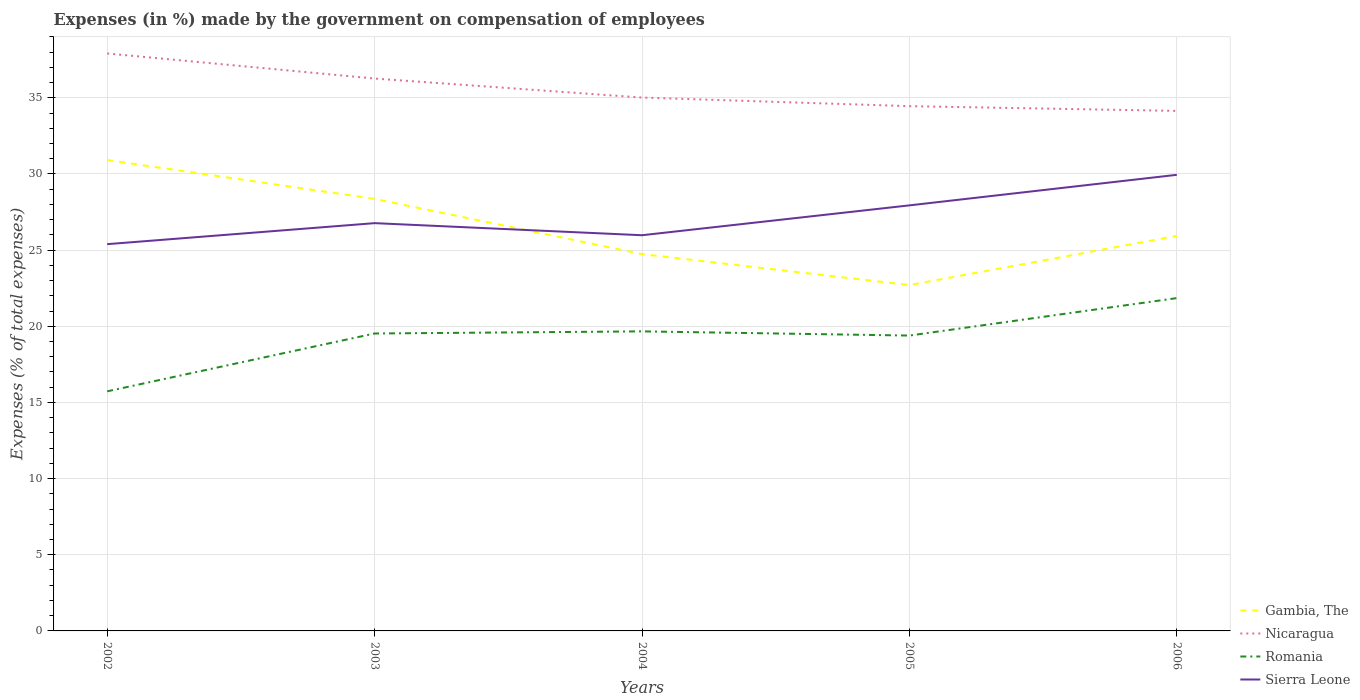How many different coloured lines are there?
Ensure brevity in your answer.  4. Does the line corresponding to Romania intersect with the line corresponding to Gambia, The?
Your response must be concise. No. Across all years, what is the maximum percentage of expenses made by the government on compensation of employees in Sierra Leone?
Your response must be concise. 25.39. What is the total percentage of expenses made by the government on compensation of employees in Nicaragua in the graph?
Your answer should be very brief. 0.88. What is the difference between the highest and the second highest percentage of expenses made by the government on compensation of employees in Romania?
Provide a succinct answer. 6.12. Are the values on the major ticks of Y-axis written in scientific E-notation?
Make the answer very short. No. Does the graph contain any zero values?
Your answer should be very brief. No. Does the graph contain grids?
Ensure brevity in your answer.  Yes. Where does the legend appear in the graph?
Provide a short and direct response. Bottom right. How are the legend labels stacked?
Your response must be concise. Vertical. What is the title of the graph?
Provide a short and direct response. Expenses (in %) made by the government on compensation of employees. Does "Moldova" appear as one of the legend labels in the graph?
Keep it short and to the point. No. What is the label or title of the X-axis?
Your answer should be very brief. Years. What is the label or title of the Y-axis?
Provide a succinct answer. Expenses (% of total expenses). What is the Expenses (% of total expenses) in Gambia, The in 2002?
Make the answer very short. 30.92. What is the Expenses (% of total expenses) of Nicaragua in 2002?
Offer a terse response. 37.91. What is the Expenses (% of total expenses) in Romania in 2002?
Your answer should be compact. 15.73. What is the Expenses (% of total expenses) of Sierra Leone in 2002?
Give a very brief answer. 25.39. What is the Expenses (% of total expenses) of Gambia, The in 2003?
Provide a short and direct response. 28.37. What is the Expenses (% of total expenses) of Nicaragua in 2003?
Ensure brevity in your answer.  36.26. What is the Expenses (% of total expenses) in Romania in 2003?
Provide a succinct answer. 19.53. What is the Expenses (% of total expenses) in Sierra Leone in 2003?
Provide a short and direct response. 26.77. What is the Expenses (% of total expenses) in Gambia, The in 2004?
Your answer should be compact. 24.74. What is the Expenses (% of total expenses) in Nicaragua in 2004?
Give a very brief answer. 35.02. What is the Expenses (% of total expenses) in Romania in 2004?
Ensure brevity in your answer.  19.67. What is the Expenses (% of total expenses) in Sierra Leone in 2004?
Offer a terse response. 25.98. What is the Expenses (% of total expenses) of Gambia, The in 2005?
Your answer should be compact. 22.71. What is the Expenses (% of total expenses) in Nicaragua in 2005?
Make the answer very short. 34.45. What is the Expenses (% of total expenses) in Romania in 2005?
Make the answer very short. 19.39. What is the Expenses (% of total expenses) of Sierra Leone in 2005?
Provide a short and direct response. 27.94. What is the Expenses (% of total expenses) of Gambia, The in 2006?
Provide a short and direct response. 25.94. What is the Expenses (% of total expenses) in Nicaragua in 2006?
Ensure brevity in your answer.  34.14. What is the Expenses (% of total expenses) in Romania in 2006?
Offer a very short reply. 21.85. What is the Expenses (% of total expenses) in Sierra Leone in 2006?
Provide a succinct answer. 29.94. Across all years, what is the maximum Expenses (% of total expenses) of Gambia, The?
Give a very brief answer. 30.92. Across all years, what is the maximum Expenses (% of total expenses) of Nicaragua?
Offer a very short reply. 37.91. Across all years, what is the maximum Expenses (% of total expenses) in Romania?
Ensure brevity in your answer.  21.85. Across all years, what is the maximum Expenses (% of total expenses) in Sierra Leone?
Your answer should be compact. 29.94. Across all years, what is the minimum Expenses (% of total expenses) of Gambia, The?
Your answer should be compact. 22.71. Across all years, what is the minimum Expenses (% of total expenses) of Nicaragua?
Provide a short and direct response. 34.14. Across all years, what is the minimum Expenses (% of total expenses) in Romania?
Keep it short and to the point. 15.73. Across all years, what is the minimum Expenses (% of total expenses) in Sierra Leone?
Your response must be concise. 25.39. What is the total Expenses (% of total expenses) of Gambia, The in the graph?
Keep it short and to the point. 132.67. What is the total Expenses (% of total expenses) of Nicaragua in the graph?
Provide a succinct answer. 177.78. What is the total Expenses (% of total expenses) in Romania in the graph?
Offer a very short reply. 96.16. What is the total Expenses (% of total expenses) in Sierra Leone in the graph?
Provide a succinct answer. 136.02. What is the difference between the Expenses (% of total expenses) in Gambia, The in 2002 and that in 2003?
Give a very brief answer. 2.55. What is the difference between the Expenses (% of total expenses) in Nicaragua in 2002 and that in 2003?
Make the answer very short. 1.65. What is the difference between the Expenses (% of total expenses) in Romania in 2002 and that in 2003?
Your response must be concise. -3.8. What is the difference between the Expenses (% of total expenses) of Sierra Leone in 2002 and that in 2003?
Give a very brief answer. -1.38. What is the difference between the Expenses (% of total expenses) of Gambia, The in 2002 and that in 2004?
Provide a succinct answer. 6.18. What is the difference between the Expenses (% of total expenses) in Nicaragua in 2002 and that in 2004?
Provide a short and direct response. 2.89. What is the difference between the Expenses (% of total expenses) in Romania in 2002 and that in 2004?
Provide a succinct answer. -3.94. What is the difference between the Expenses (% of total expenses) in Sierra Leone in 2002 and that in 2004?
Offer a very short reply. -0.59. What is the difference between the Expenses (% of total expenses) in Gambia, The in 2002 and that in 2005?
Offer a very short reply. 8.21. What is the difference between the Expenses (% of total expenses) in Nicaragua in 2002 and that in 2005?
Keep it short and to the point. 3.46. What is the difference between the Expenses (% of total expenses) of Romania in 2002 and that in 2005?
Give a very brief answer. -3.66. What is the difference between the Expenses (% of total expenses) in Sierra Leone in 2002 and that in 2005?
Keep it short and to the point. -2.55. What is the difference between the Expenses (% of total expenses) of Gambia, The in 2002 and that in 2006?
Offer a very short reply. 4.98. What is the difference between the Expenses (% of total expenses) in Nicaragua in 2002 and that in 2006?
Provide a succinct answer. 3.77. What is the difference between the Expenses (% of total expenses) in Romania in 2002 and that in 2006?
Offer a very short reply. -6.12. What is the difference between the Expenses (% of total expenses) in Sierra Leone in 2002 and that in 2006?
Your answer should be very brief. -4.55. What is the difference between the Expenses (% of total expenses) of Gambia, The in 2003 and that in 2004?
Your answer should be compact. 3.63. What is the difference between the Expenses (% of total expenses) in Nicaragua in 2003 and that in 2004?
Provide a short and direct response. 1.25. What is the difference between the Expenses (% of total expenses) of Romania in 2003 and that in 2004?
Offer a terse response. -0.14. What is the difference between the Expenses (% of total expenses) of Sierra Leone in 2003 and that in 2004?
Provide a short and direct response. 0.79. What is the difference between the Expenses (% of total expenses) of Gambia, The in 2003 and that in 2005?
Give a very brief answer. 5.66. What is the difference between the Expenses (% of total expenses) in Nicaragua in 2003 and that in 2005?
Provide a short and direct response. 1.81. What is the difference between the Expenses (% of total expenses) in Romania in 2003 and that in 2005?
Make the answer very short. 0.14. What is the difference between the Expenses (% of total expenses) of Sierra Leone in 2003 and that in 2005?
Make the answer very short. -1.17. What is the difference between the Expenses (% of total expenses) of Gambia, The in 2003 and that in 2006?
Your answer should be compact. 2.43. What is the difference between the Expenses (% of total expenses) of Nicaragua in 2003 and that in 2006?
Offer a terse response. 2.12. What is the difference between the Expenses (% of total expenses) in Romania in 2003 and that in 2006?
Ensure brevity in your answer.  -2.32. What is the difference between the Expenses (% of total expenses) in Sierra Leone in 2003 and that in 2006?
Ensure brevity in your answer.  -3.17. What is the difference between the Expenses (% of total expenses) of Gambia, The in 2004 and that in 2005?
Provide a short and direct response. 2.03. What is the difference between the Expenses (% of total expenses) in Nicaragua in 2004 and that in 2005?
Provide a short and direct response. 0.56. What is the difference between the Expenses (% of total expenses) in Romania in 2004 and that in 2005?
Offer a terse response. 0.27. What is the difference between the Expenses (% of total expenses) in Sierra Leone in 2004 and that in 2005?
Your answer should be very brief. -1.96. What is the difference between the Expenses (% of total expenses) in Gambia, The in 2004 and that in 2006?
Provide a succinct answer. -1.19. What is the difference between the Expenses (% of total expenses) of Nicaragua in 2004 and that in 2006?
Provide a succinct answer. 0.88. What is the difference between the Expenses (% of total expenses) in Romania in 2004 and that in 2006?
Provide a short and direct response. -2.18. What is the difference between the Expenses (% of total expenses) of Sierra Leone in 2004 and that in 2006?
Your answer should be compact. -3.97. What is the difference between the Expenses (% of total expenses) of Gambia, The in 2005 and that in 2006?
Keep it short and to the point. -3.23. What is the difference between the Expenses (% of total expenses) of Nicaragua in 2005 and that in 2006?
Keep it short and to the point. 0.31. What is the difference between the Expenses (% of total expenses) in Romania in 2005 and that in 2006?
Provide a short and direct response. -2.46. What is the difference between the Expenses (% of total expenses) in Sierra Leone in 2005 and that in 2006?
Provide a succinct answer. -2. What is the difference between the Expenses (% of total expenses) in Gambia, The in 2002 and the Expenses (% of total expenses) in Nicaragua in 2003?
Provide a short and direct response. -5.35. What is the difference between the Expenses (% of total expenses) in Gambia, The in 2002 and the Expenses (% of total expenses) in Romania in 2003?
Offer a terse response. 11.39. What is the difference between the Expenses (% of total expenses) in Gambia, The in 2002 and the Expenses (% of total expenses) in Sierra Leone in 2003?
Offer a very short reply. 4.14. What is the difference between the Expenses (% of total expenses) of Nicaragua in 2002 and the Expenses (% of total expenses) of Romania in 2003?
Your answer should be very brief. 18.38. What is the difference between the Expenses (% of total expenses) of Nicaragua in 2002 and the Expenses (% of total expenses) of Sierra Leone in 2003?
Ensure brevity in your answer.  11.14. What is the difference between the Expenses (% of total expenses) in Romania in 2002 and the Expenses (% of total expenses) in Sierra Leone in 2003?
Give a very brief answer. -11.04. What is the difference between the Expenses (% of total expenses) of Gambia, The in 2002 and the Expenses (% of total expenses) of Romania in 2004?
Your response must be concise. 11.25. What is the difference between the Expenses (% of total expenses) of Gambia, The in 2002 and the Expenses (% of total expenses) of Sierra Leone in 2004?
Make the answer very short. 4.94. What is the difference between the Expenses (% of total expenses) of Nicaragua in 2002 and the Expenses (% of total expenses) of Romania in 2004?
Make the answer very short. 18.25. What is the difference between the Expenses (% of total expenses) of Nicaragua in 2002 and the Expenses (% of total expenses) of Sierra Leone in 2004?
Offer a very short reply. 11.93. What is the difference between the Expenses (% of total expenses) in Romania in 2002 and the Expenses (% of total expenses) in Sierra Leone in 2004?
Provide a short and direct response. -10.25. What is the difference between the Expenses (% of total expenses) in Gambia, The in 2002 and the Expenses (% of total expenses) in Nicaragua in 2005?
Offer a terse response. -3.54. What is the difference between the Expenses (% of total expenses) in Gambia, The in 2002 and the Expenses (% of total expenses) in Romania in 2005?
Your response must be concise. 11.52. What is the difference between the Expenses (% of total expenses) of Gambia, The in 2002 and the Expenses (% of total expenses) of Sierra Leone in 2005?
Give a very brief answer. 2.98. What is the difference between the Expenses (% of total expenses) in Nicaragua in 2002 and the Expenses (% of total expenses) in Romania in 2005?
Make the answer very short. 18.52. What is the difference between the Expenses (% of total expenses) in Nicaragua in 2002 and the Expenses (% of total expenses) in Sierra Leone in 2005?
Offer a very short reply. 9.97. What is the difference between the Expenses (% of total expenses) of Romania in 2002 and the Expenses (% of total expenses) of Sierra Leone in 2005?
Your response must be concise. -12.21. What is the difference between the Expenses (% of total expenses) in Gambia, The in 2002 and the Expenses (% of total expenses) in Nicaragua in 2006?
Ensure brevity in your answer.  -3.22. What is the difference between the Expenses (% of total expenses) of Gambia, The in 2002 and the Expenses (% of total expenses) of Romania in 2006?
Provide a succinct answer. 9.07. What is the difference between the Expenses (% of total expenses) in Gambia, The in 2002 and the Expenses (% of total expenses) in Sierra Leone in 2006?
Provide a short and direct response. 0.97. What is the difference between the Expenses (% of total expenses) in Nicaragua in 2002 and the Expenses (% of total expenses) in Romania in 2006?
Provide a succinct answer. 16.06. What is the difference between the Expenses (% of total expenses) in Nicaragua in 2002 and the Expenses (% of total expenses) in Sierra Leone in 2006?
Offer a very short reply. 7.97. What is the difference between the Expenses (% of total expenses) in Romania in 2002 and the Expenses (% of total expenses) in Sierra Leone in 2006?
Provide a succinct answer. -14.21. What is the difference between the Expenses (% of total expenses) in Gambia, The in 2003 and the Expenses (% of total expenses) in Nicaragua in 2004?
Make the answer very short. -6.65. What is the difference between the Expenses (% of total expenses) in Gambia, The in 2003 and the Expenses (% of total expenses) in Romania in 2004?
Offer a terse response. 8.7. What is the difference between the Expenses (% of total expenses) in Gambia, The in 2003 and the Expenses (% of total expenses) in Sierra Leone in 2004?
Your answer should be compact. 2.39. What is the difference between the Expenses (% of total expenses) in Nicaragua in 2003 and the Expenses (% of total expenses) in Romania in 2004?
Offer a terse response. 16.6. What is the difference between the Expenses (% of total expenses) in Nicaragua in 2003 and the Expenses (% of total expenses) in Sierra Leone in 2004?
Provide a short and direct response. 10.29. What is the difference between the Expenses (% of total expenses) in Romania in 2003 and the Expenses (% of total expenses) in Sierra Leone in 2004?
Ensure brevity in your answer.  -6.45. What is the difference between the Expenses (% of total expenses) of Gambia, The in 2003 and the Expenses (% of total expenses) of Nicaragua in 2005?
Offer a very short reply. -6.09. What is the difference between the Expenses (% of total expenses) of Gambia, The in 2003 and the Expenses (% of total expenses) of Romania in 2005?
Your answer should be compact. 8.98. What is the difference between the Expenses (% of total expenses) of Gambia, The in 2003 and the Expenses (% of total expenses) of Sierra Leone in 2005?
Ensure brevity in your answer.  0.43. What is the difference between the Expenses (% of total expenses) of Nicaragua in 2003 and the Expenses (% of total expenses) of Romania in 2005?
Your response must be concise. 16.87. What is the difference between the Expenses (% of total expenses) in Nicaragua in 2003 and the Expenses (% of total expenses) in Sierra Leone in 2005?
Your response must be concise. 8.33. What is the difference between the Expenses (% of total expenses) of Romania in 2003 and the Expenses (% of total expenses) of Sierra Leone in 2005?
Your answer should be very brief. -8.41. What is the difference between the Expenses (% of total expenses) of Gambia, The in 2003 and the Expenses (% of total expenses) of Nicaragua in 2006?
Provide a succinct answer. -5.77. What is the difference between the Expenses (% of total expenses) in Gambia, The in 2003 and the Expenses (% of total expenses) in Romania in 2006?
Your answer should be compact. 6.52. What is the difference between the Expenses (% of total expenses) in Gambia, The in 2003 and the Expenses (% of total expenses) in Sierra Leone in 2006?
Keep it short and to the point. -1.58. What is the difference between the Expenses (% of total expenses) of Nicaragua in 2003 and the Expenses (% of total expenses) of Romania in 2006?
Give a very brief answer. 14.41. What is the difference between the Expenses (% of total expenses) in Nicaragua in 2003 and the Expenses (% of total expenses) in Sierra Leone in 2006?
Offer a terse response. 6.32. What is the difference between the Expenses (% of total expenses) in Romania in 2003 and the Expenses (% of total expenses) in Sierra Leone in 2006?
Provide a short and direct response. -10.42. What is the difference between the Expenses (% of total expenses) in Gambia, The in 2004 and the Expenses (% of total expenses) in Nicaragua in 2005?
Keep it short and to the point. -9.71. What is the difference between the Expenses (% of total expenses) in Gambia, The in 2004 and the Expenses (% of total expenses) in Romania in 2005?
Offer a terse response. 5.35. What is the difference between the Expenses (% of total expenses) in Gambia, The in 2004 and the Expenses (% of total expenses) in Sierra Leone in 2005?
Your answer should be compact. -3.2. What is the difference between the Expenses (% of total expenses) in Nicaragua in 2004 and the Expenses (% of total expenses) in Romania in 2005?
Your response must be concise. 15.62. What is the difference between the Expenses (% of total expenses) of Nicaragua in 2004 and the Expenses (% of total expenses) of Sierra Leone in 2005?
Provide a succinct answer. 7.08. What is the difference between the Expenses (% of total expenses) of Romania in 2004 and the Expenses (% of total expenses) of Sierra Leone in 2005?
Keep it short and to the point. -8.27. What is the difference between the Expenses (% of total expenses) of Gambia, The in 2004 and the Expenses (% of total expenses) of Nicaragua in 2006?
Your answer should be compact. -9.4. What is the difference between the Expenses (% of total expenses) of Gambia, The in 2004 and the Expenses (% of total expenses) of Romania in 2006?
Your response must be concise. 2.89. What is the difference between the Expenses (% of total expenses) of Gambia, The in 2004 and the Expenses (% of total expenses) of Sierra Leone in 2006?
Keep it short and to the point. -5.2. What is the difference between the Expenses (% of total expenses) of Nicaragua in 2004 and the Expenses (% of total expenses) of Romania in 2006?
Keep it short and to the point. 13.17. What is the difference between the Expenses (% of total expenses) of Nicaragua in 2004 and the Expenses (% of total expenses) of Sierra Leone in 2006?
Give a very brief answer. 5.07. What is the difference between the Expenses (% of total expenses) in Romania in 2004 and the Expenses (% of total expenses) in Sierra Leone in 2006?
Provide a short and direct response. -10.28. What is the difference between the Expenses (% of total expenses) of Gambia, The in 2005 and the Expenses (% of total expenses) of Nicaragua in 2006?
Keep it short and to the point. -11.43. What is the difference between the Expenses (% of total expenses) in Gambia, The in 2005 and the Expenses (% of total expenses) in Romania in 2006?
Offer a very short reply. 0.86. What is the difference between the Expenses (% of total expenses) in Gambia, The in 2005 and the Expenses (% of total expenses) in Sierra Leone in 2006?
Give a very brief answer. -7.24. What is the difference between the Expenses (% of total expenses) in Nicaragua in 2005 and the Expenses (% of total expenses) in Romania in 2006?
Your answer should be very brief. 12.6. What is the difference between the Expenses (% of total expenses) in Nicaragua in 2005 and the Expenses (% of total expenses) in Sierra Leone in 2006?
Provide a succinct answer. 4.51. What is the difference between the Expenses (% of total expenses) in Romania in 2005 and the Expenses (% of total expenses) in Sierra Leone in 2006?
Your answer should be compact. -10.55. What is the average Expenses (% of total expenses) in Gambia, The per year?
Give a very brief answer. 26.53. What is the average Expenses (% of total expenses) of Nicaragua per year?
Offer a very short reply. 35.56. What is the average Expenses (% of total expenses) of Romania per year?
Provide a short and direct response. 19.23. What is the average Expenses (% of total expenses) of Sierra Leone per year?
Provide a succinct answer. 27.2. In the year 2002, what is the difference between the Expenses (% of total expenses) in Gambia, The and Expenses (% of total expenses) in Nicaragua?
Offer a very short reply. -6.99. In the year 2002, what is the difference between the Expenses (% of total expenses) in Gambia, The and Expenses (% of total expenses) in Romania?
Keep it short and to the point. 15.19. In the year 2002, what is the difference between the Expenses (% of total expenses) of Gambia, The and Expenses (% of total expenses) of Sierra Leone?
Make the answer very short. 5.52. In the year 2002, what is the difference between the Expenses (% of total expenses) in Nicaragua and Expenses (% of total expenses) in Romania?
Your response must be concise. 22.18. In the year 2002, what is the difference between the Expenses (% of total expenses) in Nicaragua and Expenses (% of total expenses) in Sierra Leone?
Your response must be concise. 12.52. In the year 2002, what is the difference between the Expenses (% of total expenses) in Romania and Expenses (% of total expenses) in Sierra Leone?
Your answer should be very brief. -9.66. In the year 2003, what is the difference between the Expenses (% of total expenses) in Gambia, The and Expenses (% of total expenses) in Nicaragua?
Your answer should be very brief. -7.9. In the year 2003, what is the difference between the Expenses (% of total expenses) of Gambia, The and Expenses (% of total expenses) of Romania?
Give a very brief answer. 8.84. In the year 2003, what is the difference between the Expenses (% of total expenses) in Gambia, The and Expenses (% of total expenses) in Sierra Leone?
Provide a short and direct response. 1.6. In the year 2003, what is the difference between the Expenses (% of total expenses) in Nicaragua and Expenses (% of total expenses) in Romania?
Your response must be concise. 16.74. In the year 2003, what is the difference between the Expenses (% of total expenses) of Nicaragua and Expenses (% of total expenses) of Sierra Leone?
Your response must be concise. 9.49. In the year 2003, what is the difference between the Expenses (% of total expenses) of Romania and Expenses (% of total expenses) of Sierra Leone?
Your answer should be compact. -7.24. In the year 2004, what is the difference between the Expenses (% of total expenses) in Gambia, The and Expenses (% of total expenses) in Nicaragua?
Your response must be concise. -10.28. In the year 2004, what is the difference between the Expenses (% of total expenses) in Gambia, The and Expenses (% of total expenses) in Romania?
Your answer should be very brief. 5.07. In the year 2004, what is the difference between the Expenses (% of total expenses) of Gambia, The and Expenses (% of total expenses) of Sierra Leone?
Offer a terse response. -1.24. In the year 2004, what is the difference between the Expenses (% of total expenses) of Nicaragua and Expenses (% of total expenses) of Romania?
Offer a very short reply. 15.35. In the year 2004, what is the difference between the Expenses (% of total expenses) in Nicaragua and Expenses (% of total expenses) in Sierra Leone?
Your response must be concise. 9.04. In the year 2004, what is the difference between the Expenses (% of total expenses) of Romania and Expenses (% of total expenses) of Sierra Leone?
Keep it short and to the point. -6.31. In the year 2005, what is the difference between the Expenses (% of total expenses) of Gambia, The and Expenses (% of total expenses) of Nicaragua?
Your answer should be very brief. -11.74. In the year 2005, what is the difference between the Expenses (% of total expenses) in Gambia, The and Expenses (% of total expenses) in Romania?
Provide a succinct answer. 3.32. In the year 2005, what is the difference between the Expenses (% of total expenses) in Gambia, The and Expenses (% of total expenses) in Sierra Leone?
Your answer should be compact. -5.23. In the year 2005, what is the difference between the Expenses (% of total expenses) in Nicaragua and Expenses (% of total expenses) in Romania?
Offer a terse response. 15.06. In the year 2005, what is the difference between the Expenses (% of total expenses) of Nicaragua and Expenses (% of total expenses) of Sierra Leone?
Offer a terse response. 6.51. In the year 2005, what is the difference between the Expenses (% of total expenses) in Romania and Expenses (% of total expenses) in Sierra Leone?
Offer a terse response. -8.55. In the year 2006, what is the difference between the Expenses (% of total expenses) of Gambia, The and Expenses (% of total expenses) of Nicaragua?
Your answer should be compact. -8.21. In the year 2006, what is the difference between the Expenses (% of total expenses) in Gambia, The and Expenses (% of total expenses) in Romania?
Offer a terse response. 4.08. In the year 2006, what is the difference between the Expenses (% of total expenses) in Gambia, The and Expenses (% of total expenses) in Sierra Leone?
Keep it short and to the point. -4.01. In the year 2006, what is the difference between the Expenses (% of total expenses) of Nicaragua and Expenses (% of total expenses) of Romania?
Offer a very short reply. 12.29. In the year 2006, what is the difference between the Expenses (% of total expenses) in Nicaragua and Expenses (% of total expenses) in Sierra Leone?
Provide a short and direct response. 4.2. In the year 2006, what is the difference between the Expenses (% of total expenses) of Romania and Expenses (% of total expenses) of Sierra Leone?
Your response must be concise. -8.09. What is the ratio of the Expenses (% of total expenses) in Gambia, The in 2002 to that in 2003?
Make the answer very short. 1.09. What is the ratio of the Expenses (% of total expenses) of Nicaragua in 2002 to that in 2003?
Ensure brevity in your answer.  1.05. What is the ratio of the Expenses (% of total expenses) in Romania in 2002 to that in 2003?
Ensure brevity in your answer.  0.81. What is the ratio of the Expenses (% of total expenses) in Sierra Leone in 2002 to that in 2003?
Keep it short and to the point. 0.95. What is the ratio of the Expenses (% of total expenses) of Gambia, The in 2002 to that in 2004?
Ensure brevity in your answer.  1.25. What is the ratio of the Expenses (% of total expenses) in Nicaragua in 2002 to that in 2004?
Give a very brief answer. 1.08. What is the ratio of the Expenses (% of total expenses) of Romania in 2002 to that in 2004?
Offer a terse response. 0.8. What is the ratio of the Expenses (% of total expenses) of Sierra Leone in 2002 to that in 2004?
Offer a very short reply. 0.98. What is the ratio of the Expenses (% of total expenses) of Gambia, The in 2002 to that in 2005?
Your answer should be very brief. 1.36. What is the ratio of the Expenses (% of total expenses) of Nicaragua in 2002 to that in 2005?
Offer a terse response. 1.1. What is the ratio of the Expenses (% of total expenses) of Romania in 2002 to that in 2005?
Give a very brief answer. 0.81. What is the ratio of the Expenses (% of total expenses) of Sierra Leone in 2002 to that in 2005?
Keep it short and to the point. 0.91. What is the ratio of the Expenses (% of total expenses) of Gambia, The in 2002 to that in 2006?
Keep it short and to the point. 1.19. What is the ratio of the Expenses (% of total expenses) in Nicaragua in 2002 to that in 2006?
Give a very brief answer. 1.11. What is the ratio of the Expenses (% of total expenses) of Romania in 2002 to that in 2006?
Ensure brevity in your answer.  0.72. What is the ratio of the Expenses (% of total expenses) in Sierra Leone in 2002 to that in 2006?
Your answer should be compact. 0.85. What is the ratio of the Expenses (% of total expenses) in Gambia, The in 2003 to that in 2004?
Offer a very short reply. 1.15. What is the ratio of the Expenses (% of total expenses) of Nicaragua in 2003 to that in 2004?
Your answer should be compact. 1.04. What is the ratio of the Expenses (% of total expenses) in Romania in 2003 to that in 2004?
Offer a terse response. 0.99. What is the ratio of the Expenses (% of total expenses) in Sierra Leone in 2003 to that in 2004?
Your response must be concise. 1.03. What is the ratio of the Expenses (% of total expenses) of Gambia, The in 2003 to that in 2005?
Make the answer very short. 1.25. What is the ratio of the Expenses (% of total expenses) in Nicaragua in 2003 to that in 2005?
Provide a succinct answer. 1.05. What is the ratio of the Expenses (% of total expenses) in Sierra Leone in 2003 to that in 2005?
Keep it short and to the point. 0.96. What is the ratio of the Expenses (% of total expenses) of Gambia, The in 2003 to that in 2006?
Your response must be concise. 1.09. What is the ratio of the Expenses (% of total expenses) in Nicaragua in 2003 to that in 2006?
Keep it short and to the point. 1.06. What is the ratio of the Expenses (% of total expenses) of Romania in 2003 to that in 2006?
Offer a terse response. 0.89. What is the ratio of the Expenses (% of total expenses) of Sierra Leone in 2003 to that in 2006?
Your response must be concise. 0.89. What is the ratio of the Expenses (% of total expenses) in Gambia, The in 2004 to that in 2005?
Your answer should be very brief. 1.09. What is the ratio of the Expenses (% of total expenses) of Nicaragua in 2004 to that in 2005?
Offer a very short reply. 1.02. What is the ratio of the Expenses (% of total expenses) of Romania in 2004 to that in 2005?
Your response must be concise. 1.01. What is the ratio of the Expenses (% of total expenses) of Sierra Leone in 2004 to that in 2005?
Give a very brief answer. 0.93. What is the ratio of the Expenses (% of total expenses) of Gambia, The in 2004 to that in 2006?
Provide a short and direct response. 0.95. What is the ratio of the Expenses (% of total expenses) in Nicaragua in 2004 to that in 2006?
Ensure brevity in your answer.  1.03. What is the ratio of the Expenses (% of total expenses) of Romania in 2004 to that in 2006?
Offer a very short reply. 0.9. What is the ratio of the Expenses (% of total expenses) in Sierra Leone in 2004 to that in 2006?
Offer a terse response. 0.87. What is the ratio of the Expenses (% of total expenses) of Gambia, The in 2005 to that in 2006?
Your answer should be compact. 0.88. What is the ratio of the Expenses (% of total expenses) in Nicaragua in 2005 to that in 2006?
Provide a short and direct response. 1.01. What is the ratio of the Expenses (% of total expenses) in Romania in 2005 to that in 2006?
Provide a succinct answer. 0.89. What is the ratio of the Expenses (% of total expenses) of Sierra Leone in 2005 to that in 2006?
Provide a short and direct response. 0.93. What is the difference between the highest and the second highest Expenses (% of total expenses) of Gambia, The?
Your answer should be very brief. 2.55. What is the difference between the highest and the second highest Expenses (% of total expenses) of Nicaragua?
Offer a terse response. 1.65. What is the difference between the highest and the second highest Expenses (% of total expenses) in Romania?
Provide a succinct answer. 2.18. What is the difference between the highest and the second highest Expenses (% of total expenses) of Sierra Leone?
Your answer should be compact. 2. What is the difference between the highest and the lowest Expenses (% of total expenses) in Gambia, The?
Ensure brevity in your answer.  8.21. What is the difference between the highest and the lowest Expenses (% of total expenses) of Nicaragua?
Your response must be concise. 3.77. What is the difference between the highest and the lowest Expenses (% of total expenses) in Romania?
Offer a very short reply. 6.12. What is the difference between the highest and the lowest Expenses (% of total expenses) in Sierra Leone?
Make the answer very short. 4.55. 